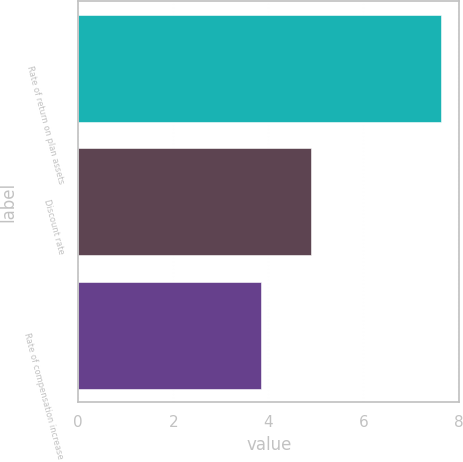Convert chart. <chart><loc_0><loc_0><loc_500><loc_500><bar_chart><fcel>Rate of return on plan assets<fcel>Discount rate<fcel>Rate of compensation increase<nl><fcel>7.64<fcel>4.89<fcel>3.84<nl></chart> 